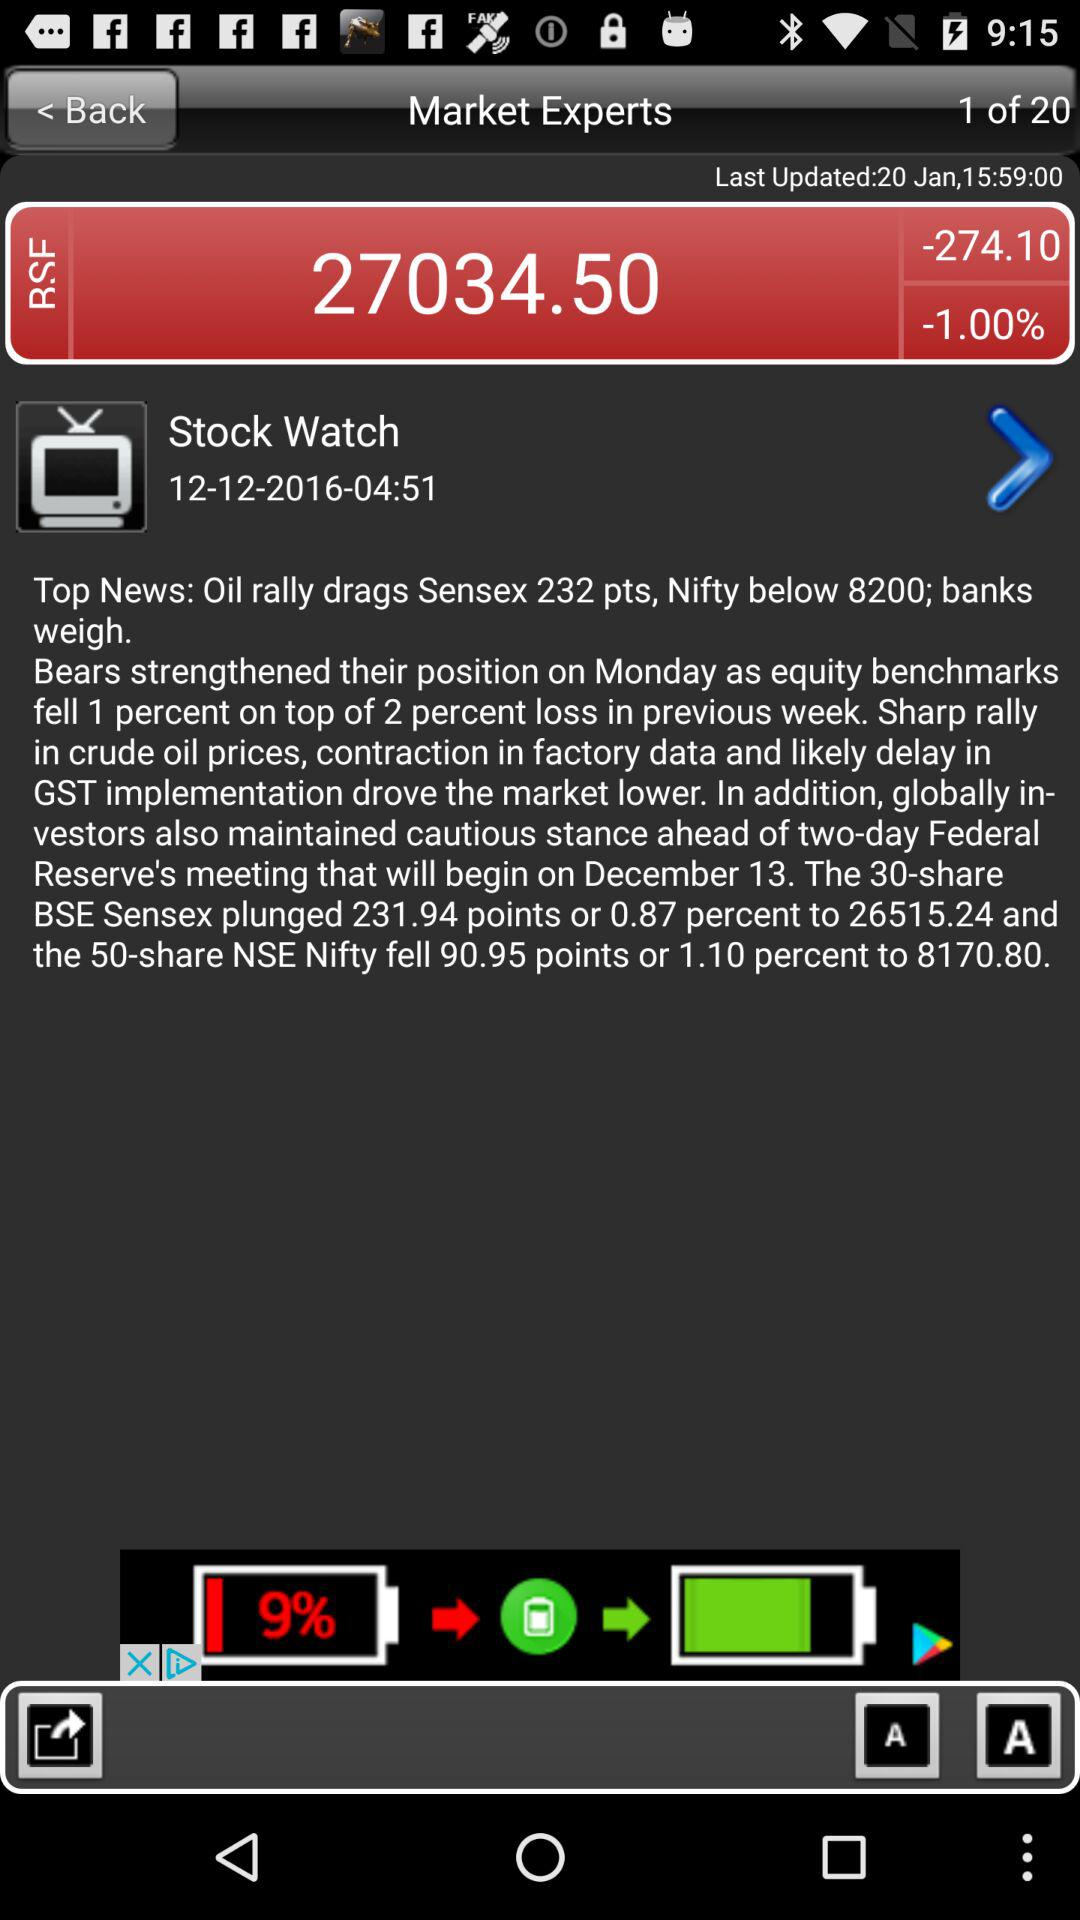How many pages in total are there? There are 20 pages. 